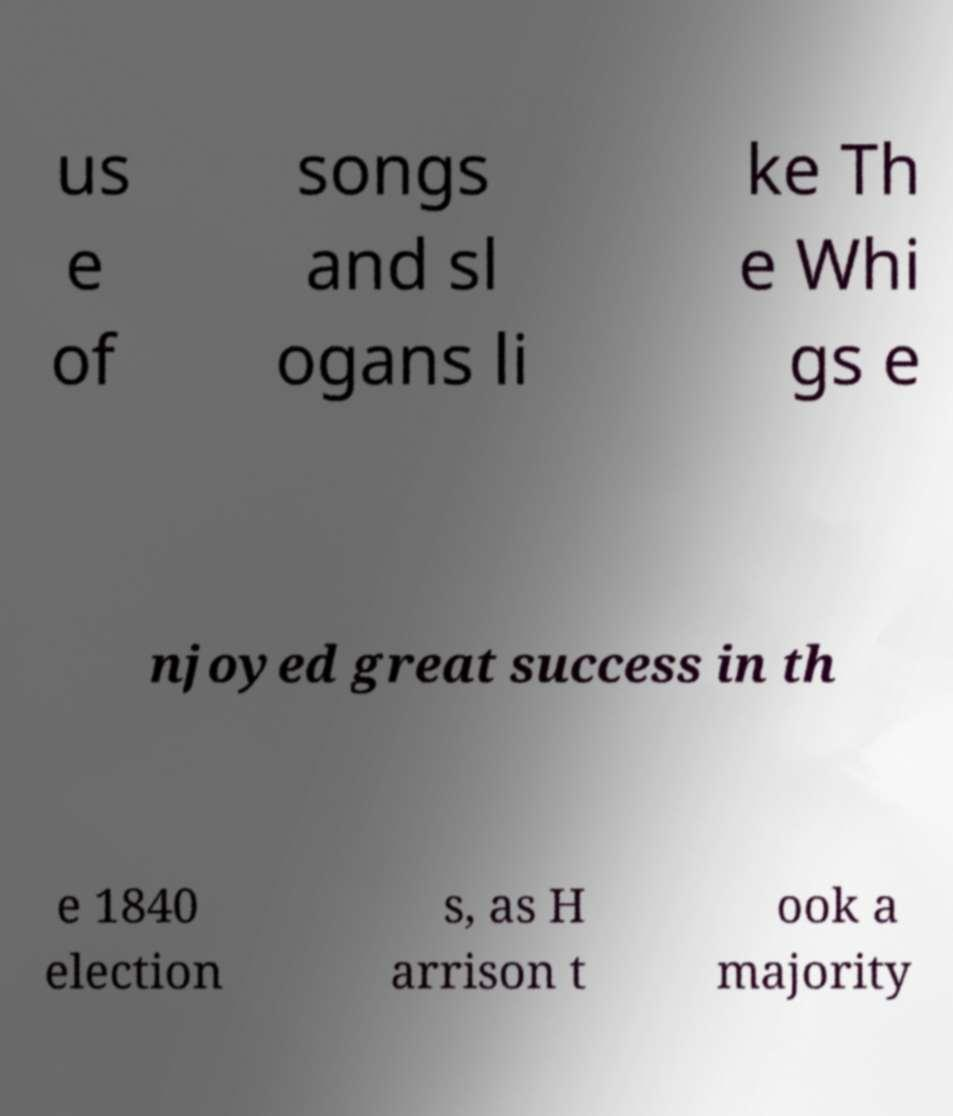There's text embedded in this image that I need extracted. Can you transcribe it verbatim? us e of songs and sl ogans li ke Th e Whi gs e njoyed great success in th e 1840 election s, as H arrison t ook a majority 